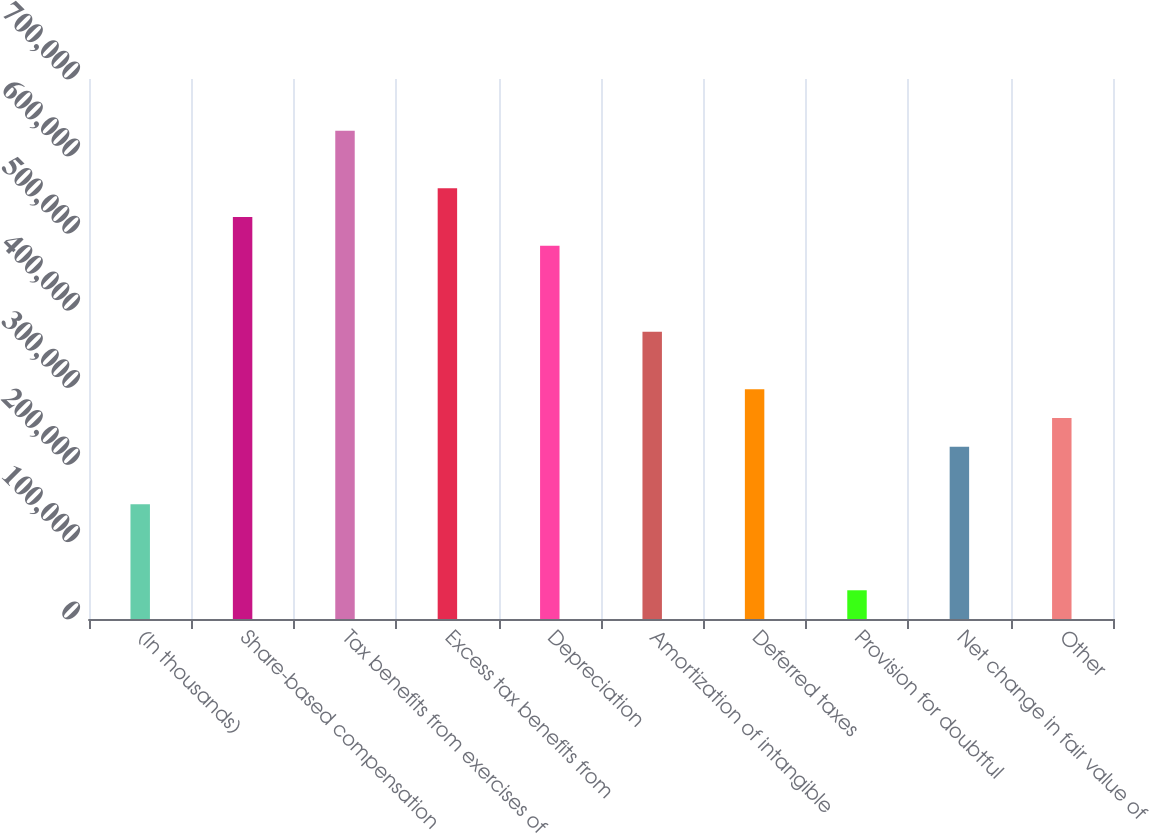<chart> <loc_0><loc_0><loc_500><loc_500><bar_chart><fcel>(In thousands)<fcel>Share-based compensation<fcel>Tax benefits from exercises of<fcel>Excess tax benefits from<fcel>Depreciation<fcel>Amortization of intangible<fcel>Deferred taxes<fcel>Provision for doubtful<fcel>Net change in fair value of<fcel>Other<nl><fcel>148898<fcel>521113<fcel>632778<fcel>558334<fcel>483892<fcel>372227<fcel>297784<fcel>37233.5<fcel>223341<fcel>260562<nl></chart> 